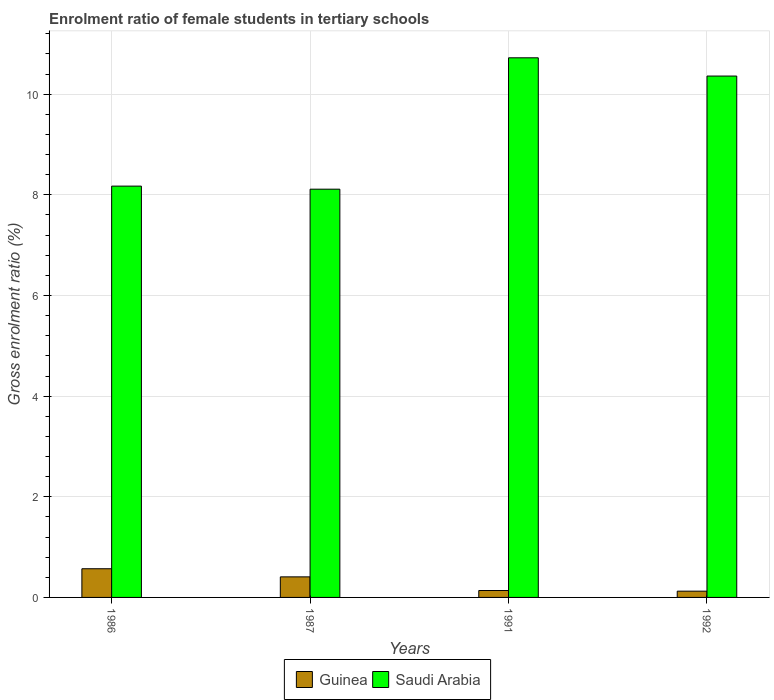How many different coloured bars are there?
Offer a terse response. 2. How many bars are there on the 1st tick from the left?
Provide a succinct answer. 2. What is the enrolment ratio of female students in tertiary schools in Saudi Arabia in 1991?
Keep it short and to the point. 10.72. Across all years, what is the maximum enrolment ratio of female students in tertiary schools in Guinea?
Keep it short and to the point. 0.57. Across all years, what is the minimum enrolment ratio of female students in tertiary schools in Saudi Arabia?
Make the answer very short. 8.11. What is the total enrolment ratio of female students in tertiary schools in Guinea in the graph?
Give a very brief answer. 1.24. What is the difference between the enrolment ratio of female students in tertiary schools in Saudi Arabia in 1987 and that in 1991?
Provide a short and direct response. -2.61. What is the difference between the enrolment ratio of female students in tertiary schools in Guinea in 1986 and the enrolment ratio of female students in tertiary schools in Saudi Arabia in 1987?
Give a very brief answer. -7.54. What is the average enrolment ratio of female students in tertiary schools in Saudi Arabia per year?
Your answer should be compact. 9.34. In the year 1992, what is the difference between the enrolment ratio of female students in tertiary schools in Guinea and enrolment ratio of female students in tertiary schools in Saudi Arabia?
Provide a succinct answer. -10.24. What is the ratio of the enrolment ratio of female students in tertiary schools in Guinea in 1986 to that in 1991?
Keep it short and to the point. 4.15. Is the difference between the enrolment ratio of female students in tertiary schools in Guinea in 1986 and 1987 greater than the difference between the enrolment ratio of female students in tertiary schools in Saudi Arabia in 1986 and 1987?
Your answer should be very brief. Yes. What is the difference between the highest and the second highest enrolment ratio of female students in tertiary schools in Saudi Arabia?
Offer a very short reply. 0.36. What is the difference between the highest and the lowest enrolment ratio of female students in tertiary schools in Saudi Arabia?
Offer a terse response. 2.61. In how many years, is the enrolment ratio of female students in tertiary schools in Guinea greater than the average enrolment ratio of female students in tertiary schools in Guinea taken over all years?
Keep it short and to the point. 2. Is the sum of the enrolment ratio of female students in tertiary schools in Saudi Arabia in 1991 and 1992 greater than the maximum enrolment ratio of female students in tertiary schools in Guinea across all years?
Offer a terse response. Yes. What does the 2nd bar from the left in 1991 represents?
Keep it short and to the point. Saudi Arabia. What does the 1st bar from the right in 1992 represents?
Offer a terse response. Saudi Arabia. How many years are there in the graph?
Your answer should be very brief. 4. What is the difference between two consecutive major ticks on the Y-axis?
Provide a succinct answer. 2. Are the values on the major ticks of Y-axis written in scientific E-notation?
Ensure brevity in your answer.  No. Does the graph contain grids?
Provide a short and direct response. Yes. Where does the legend appear in the graph?
Make the answer very short. Bottom center. How are the legend labels stacked?
Offer a terse response. Horizontal. What is the title of the graph?
Make the answer very short. Enrolment ratio of female students in tertiary schools. Does "China" appear as one of the legend labels in the graph?
Provide a succinct answer. No. What is the label or title of the Y-axis?
Provide a succinct answer. Gross enrolment ratio (%). What is the Gross enrolment ratio (%) of Guinea in 1986?
Your answer should be very brief. 0.57. What is the Gross enrolment ratio (%) in Saudi Arabia in 1986?
Provide a succinct answer. 8.17. What is the Gross enrolment ratio (%) in Guinea in 1987?
Offer a terse response. 0.41. What is the Gross enrolment ratio (%) of Saudi Arabia in 1987?
Your response must be concise. 8.11. What is the Gross enrolment ratio (%) in Guinea in 1991?
Ensure brevity in your answer.  0.14. What is the Gross enrolment ratio (%) of Saudi Arabia in 1991?
Your answer should be compact. 10.72. What is the Gross enrolment ratio (%) of Guinea in 1992?
Your response must be concise. 0.12. What is the Gross enrolment ratio (%) of Saudi Arabia in 1992?
Provide a succinct answer. 10.36. Across all years, what is the maximum Gross enrolment ratio (%) of Guinea?
Your answer should be very brief. 0.57. Across all years, what is the maximum Gross enrolment ratio (%) of Saudi Arabia?
Provide a succinct answer. 10.72. Across all years, what is the minimum Gross enrolment ratio (%) in Guinea?
Your response must be concise. 0.12. Across all years, what is the minimum Gross enrolment ratio (%) of Saudi Arabia?
Your answer should be compact. 8.11. What is the total Gross enrolment ratio (%) in Guinea in the graph?
Provide a succinct answer. 1.24. What is the total Gross enrolment ratio (%) of Saudi Arabia in the graph?
Keep it short and to the point. 37.37. What is the difference between the Gross enrolment ratio (%) in Guinea in 1986 and that in 1987?
Offer a terse response. 0.16. What is the difference between the Gross enrolment ratio (%) of Saudi Arabia in 1986 and that in 1987?
Provide a succinct answer. 0.06. What is the difference between the Gross enrolment ratio (%) in Guinea in 1986 and that in 1991?
Give a very brief answer. 0.43. What is the difference between the Gross enrolment ratio (%) in Saudi Arabia in 1986 and that in 1991?
Offer a terse response. -2.55. What is the difference between the Gross enrolment ratio (%) of Guinea in 1986 and that in 1992?
Ensure brevity in your answer.  0.45. What is the difference between the Gross enrolment ratio (%) of Saudi Arabia in 1986 and that in 1992?
Your answer should be compact. -2.19. What is the difference between the Gross enrolment ratio (%) in Guinea in 1987 and that in 1991?
Make the answer very short. 0.27. What is the difference between the Gross enrolment ratio (%) of Saudi Arabia in 1987 and that in 1991?
Ensure brevity in your answer.  -2.61. What is the difference between the Gross enrolment ratio (%) in Guinea in 1987 and that in 1992?
Offer a very short reply. 0.28. What is the difference between the Gross enrolment ratio (%) of Saudi Arabia in 1987 and that in 1992?
Make the answer very short. -2.25. What is the difference between the Gross enrolment ratio (%) of Guinea in 1991 and that in 1992?
Provide a short and direct response. 0.01. What is the difference between the Gross enrolment ratio (%) in Saudi Arabia in 1991 and that in 1992?
Provide a succinct answer. 0.36. What is the difference between the Gross enrolment ratio (%) in Guinea in 1986 and the Gross enrolment ratio (%) in Saudi Arabia in 1987?
Offer a terse response. -7.54. What is the difference between the Gross enrolment ratio (%) in Guinea in 1986 and the Gross enrolment ratio (%) in Saudi Arabia in 1991?
Give a very brief answer. -10.15. What is the difference between the Gross enrolment ratio (%) of Guinea in 1986 and the Gross enrolment ratio (%) of Saudi Arabia in 1992?
Your answer should be very brief. -9.79. What is the difference between the Gross enrolment ratio (%) of Guinea in 1987 and the Gross enrolment ratio (%) of Saudi Arabia in 1991?
Provide a short and direct response. -10.31. What is the difference between the Gross enrolment ratio (%) of Guinea in 1987 and the Gross enrolment ratio (%) of Saudi Arabia in 1992?
Your response must be concise. -9.95. What is the difference between the Gross enrolment ratio (%) in Guinea in 1991 and the Gross enrolment ratio (%) in Saudi Arabia in 1992?
Provide a short and direct response. -10.22. What is the average Gross enrolment ratio (%) of Guinea per year?
Your answer should be compact. 0.31. What is the average Gross enrolment ratio (%) of Saudi Arabia per year?
Keep it short and to the point. 9.34. In the year 1986, what is the difference between the Gross enrolment ratio (%) of Guinea and Gross enrolment ratio (%) of Saudi Arabia?
Keep it short and to the point. -7.6. In the year 1987, what is the difference between the Gross enrolment ratio (%) of Guinea and Gross enrolment ratio (%) of Saudi Arabia?
Offer a very short reply. -7.7. In the year 1991, what is the difference between the Gross enrolment ratio (%) in Guinea and Gross enrolment ratio (%) in Saudi Arabia?
Your answer should be compact. -10.59. In the year 1992, what is the difference between the Gross enrolment ratio (%) in Guinea and Gross enrolment ratio (%) in Saudi Arabia?
Your answer should be compact. -10.24. What is the ratio of the Gross enrolment ratio (%) in Guinea in 1986 to that in 1987?
Keep it short and to the point. 1.4. What is the ratio of the Gross enrolment ratio (%) in Saudi Arabia in 1986 to that in 1987?
Make the answer very short. 1.01. What is the ratio of the Gross enrolment ratio (%) of Guinea in 1986 to that in 1991?
Provide a succinct answer. 4.15. What is the ratio of the Gross enrolment ratio (%) of Saudi Arabia in 1986 to that in 1991?
Keep it short and to the point. 0.76. What is the ratio of the Gross enrolment ratio (%) in Guinea in 1986 to that in 1992?
Ensure brevity in your answer.  4.58. What is the ratio of the Gross enrolment ratio (%) in Saudi Arabia in 1986 to that in 1992?
Provide a short and direct response. 0.79. What is the ratio of the Gross enrolment ratio (%) in Guinea in 1987 to that in 1991?
Provide a short and direct response. 2.97. What is the ratio of the Gross enrolment ratio (%) in Saudi Arabia in 1987 to that in 1991?
Your answer should be compact. 0.76. What is the ratio of the Gross enrolment ratio (%) of Guinea in 1987 to that in 1992?
Provide a short and direct response. 3.28. What is the ratio of the Gross enrolment ratio (%) of Saudi Arabia in 1987 to that in 1992?
Keep it short and to the point. 0.78. What is the ratio of the Gross enrolment ratio (%) of Guinea in 1991 to that in 1992?
Your answer should be compact. 1.1. What is the ratio of the Gross enrolment ratio (%) of Saudi Arabia in 1991 to that in 1992?
Provide a short and direct response. 1.03. What is the difference between the highest and the second highest Gross enrolment ratio (%) in Guinea?
Make the answer very short. 0.16. What is the difference between the highest and the second highest Gross enrolment ratio (%) of Saudi Arabia?
Offer a terse response. 0.36. What is the difference between the highest and the lowest Gross enrolment ratio (%) of Guinea?
Keep it short and to the point. 0.45. What is the difference between the highest and the lowest Gross enrolment ratio (%) in Saudi Arabia?
Ensure brevity in your answer.  2.61. 